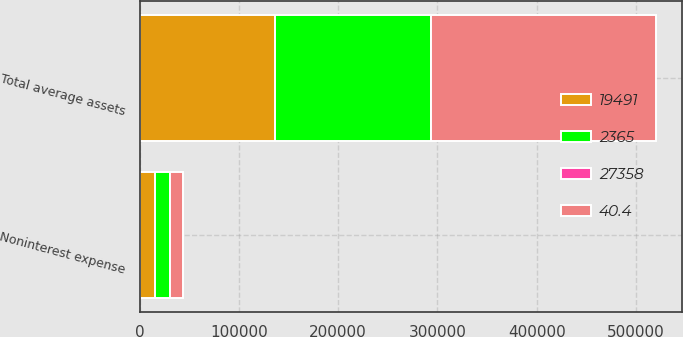<chart> <loc_0><loc_0><loc_500><loc_500><stacked_bar_chart><ecel><fcel>Noninterest expense<fcel>Total average assets<nl><fcel>40.4<fcel>13079<fcel>226423<nl><fcel>2365<fcel>15652<fcel>157461<nl><fcel>27358<fcel>16.4<fcel>43.8<nl><fcel>19491<fcel>15140<fcel>136176<nl></chart> 